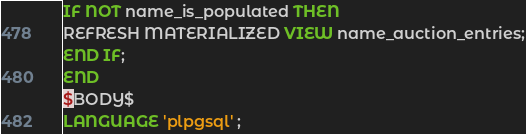Convert code to text. <code><loc_0><loc_0><loc_500><loc_500><_SQL_>IF NOT name_is_populated THEN
REFRESH MATERIALIZED VIEW name_auction_entries;
END IF;
END
$BODY$
LANGUAGE 'plpgsql' ;
</code> 